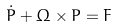Convert formula to latex. <formula><loc_0><loc_0><loc_500><loc_500>\dot { P } + { \Omega } \times { P } = { F }</formula> 